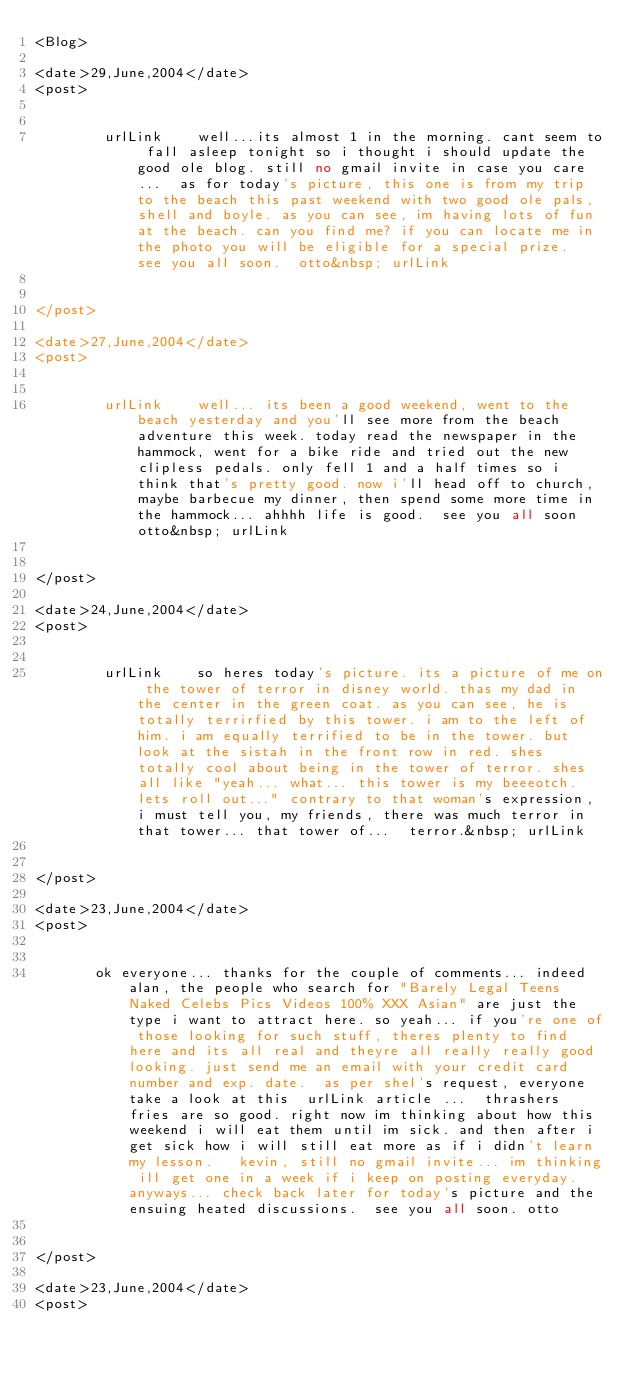<code> <loc_0><loc_0><loc_500><loc_500><_XML_><Blog>

<date>29,June,2004</date>
<post>

    
        urlLink    well...its almost 1 in the morning. cant seem to fall asleep tonight so i thought i should update the good ole blog. still no gmail invite in case you care...  as for today's picture, this one is from my trip to the beach this past weekend with two good ole pals, shell and boyle. as you can see, im having lots of fun at the beach. can you find me? if you can locate me in the photo you will be eligible for a special prize.  see you all soon.  otto&nbsp; urlLink    
    
    
</post>

<date>27,June,2004</date>
<post>

    
        urlLink    well... its been a good weekend, went to the beach yesterday and you'll see more from the beach adventure this week. today read the newspaper in the hammock, went for a bike ride and tried out the new clipless pedals. only fell 1 and a half times so i think that's pretty good. now i'll head off to church, maybe barbecue my dinner, then spend some more time in the hammock... ahhhh life is good.  see you all soon otto&nbsp; urlLink    
    
    
</post>

<date>24,June,2004</date>
<post>

    
        urlLink    so heres today's picture. its a picture of me on the tower of terror in disney world. thas my dad in the center in the green coat. as you can see, he is totally terrirfied by this tower. i am to the left of him. i am equally terrified to be in the tower. but look at the sistah in the front row in red. shes totally cool about being in the tower of terror. shes all like "yeah... what... this tower is my beeeotch. lets roll out..." contrary to that woman's expression, i must tell you, my friends, there was much terror in that tower... that tower of...  terror.&nbsp; urlLink    
    
    
</post>

<date>23,June,2004</date>
<post>

    
       ok everyone... thanks for the couple of comments... indeed alan, the people who search for "Barely Legal Teens Naked Celebs Pics Videos 100% XXX Asian" are just the type i want to attract here. so yeah... if you're one of those looking for such stuff, theres plenty to find here and its all real and theyre all really really good looking. just send me an email with your credit card number and exp. date.  as per shel's request, everyone take a look at this  urlLink article ...  thrashers fries are so good. right now im thinking about how this weekend i will eat them until im sick. and then after i get sick how i will still eat more as if i didn't learn my lesson.   kevin, still no gmail invite... im thinking ill get one in a week if i keep on posting everyday.  anyways... check back later for today's picture and the ensuing heated discussions.  see you all soon. otto   
    
    
</post>

<date>23,June,2004</date>
<post>

    </code> 